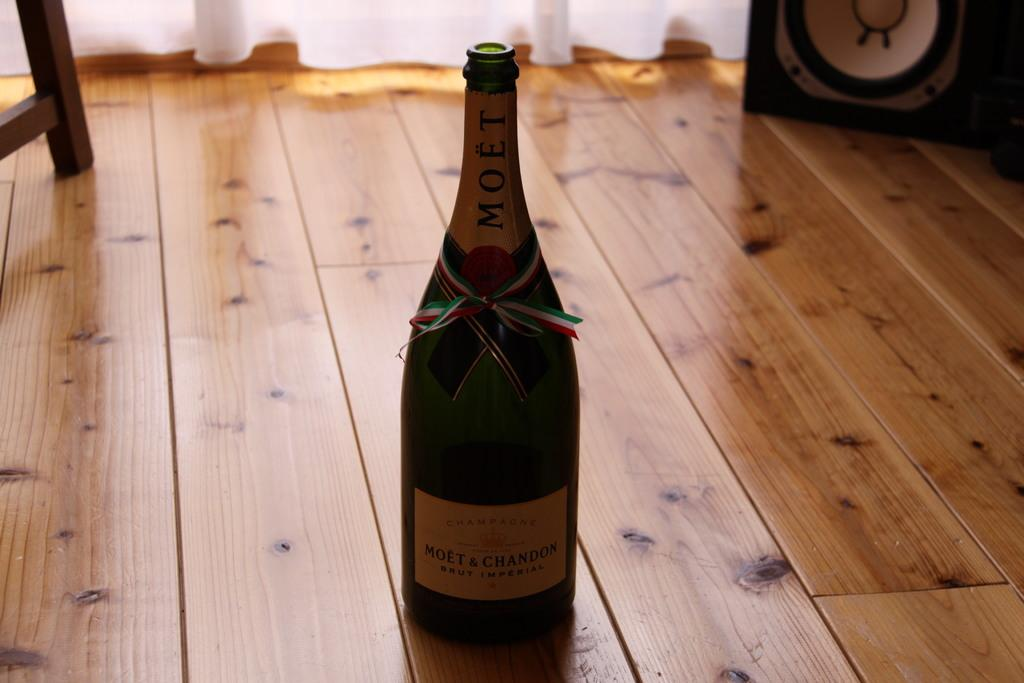<image>
Provide a brief description of the given image. A bottle of Moet is sitting on a wooden floor. 